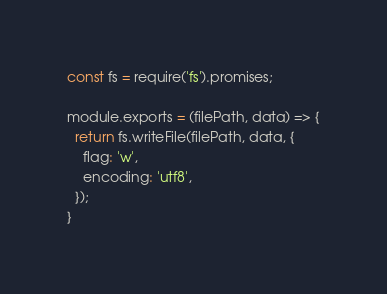Convert code to text. <code><loc_0><loc_0><loc_500><loc_500><_JavaScript_>const fs = require('fs').promises;

module.exports = (filePath, data) => {
  return fs.writeFile(filePath, data, {
    flag: 'w',
    encoding: 'utf8',
  });
}
</code> 